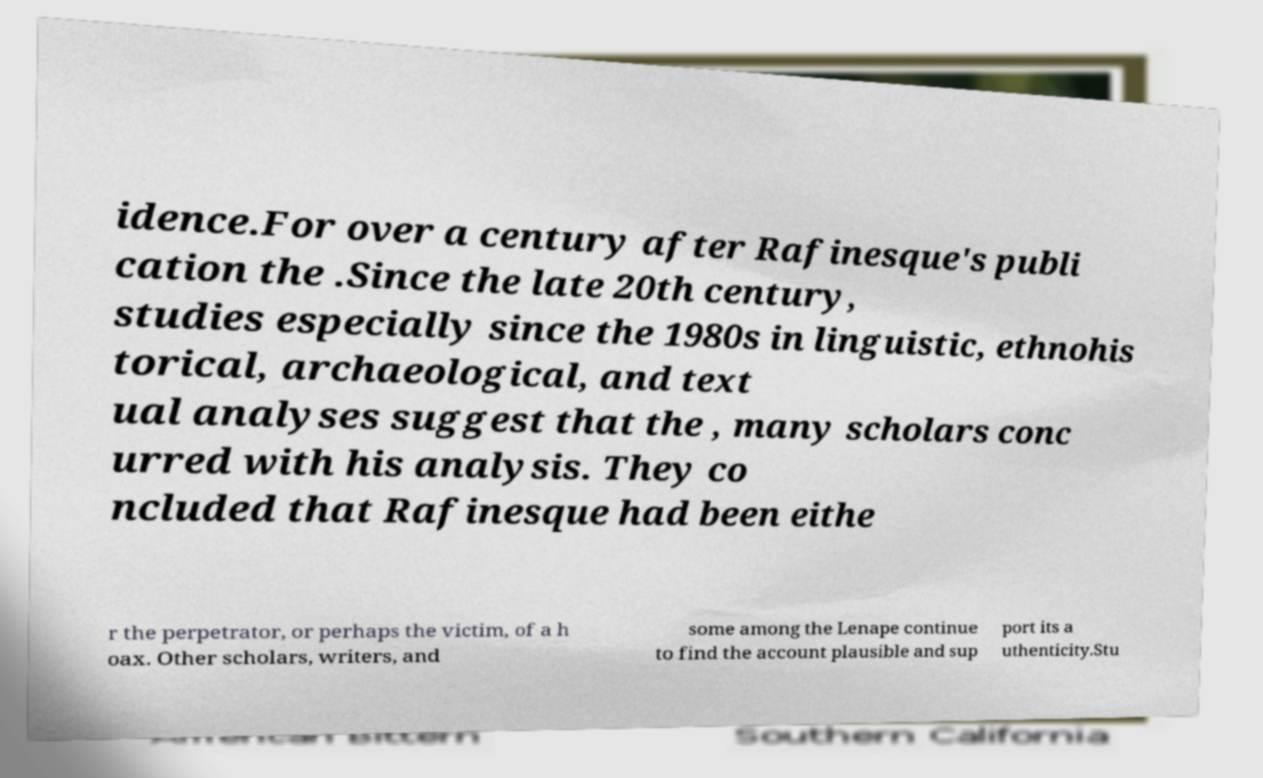What messages or text are displayed in this image? I need them in a readable, typed format. idence.For over a century after Rafinesque's publi cation the .Since the late 20th century, studies especially since the 1980s in linguistic, ethnohis torical, archaeological, and text ual analyses suggest that the , many scholars conc urred with his analysis. They co ncluded that Rafinesque had been eithe r the perpetrator, or perhaps the victim, of a h oax. Other scholars, writers, and some among the Lenape continue to find the account plausible and sup port its a uthenticity.Stu 